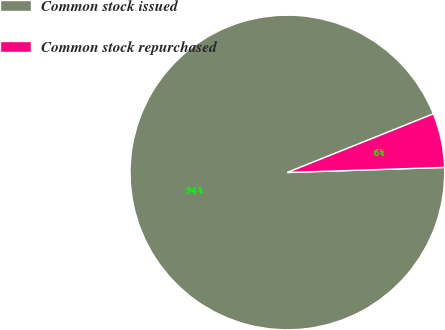<chart> <loc_0><loc_0><loc_500><loc_500><pie_chart><fcel>Common stock issued<fcel>Common stock repurchased<nl><fcel>94.44%<fcel>5.56%<nl></chart> 